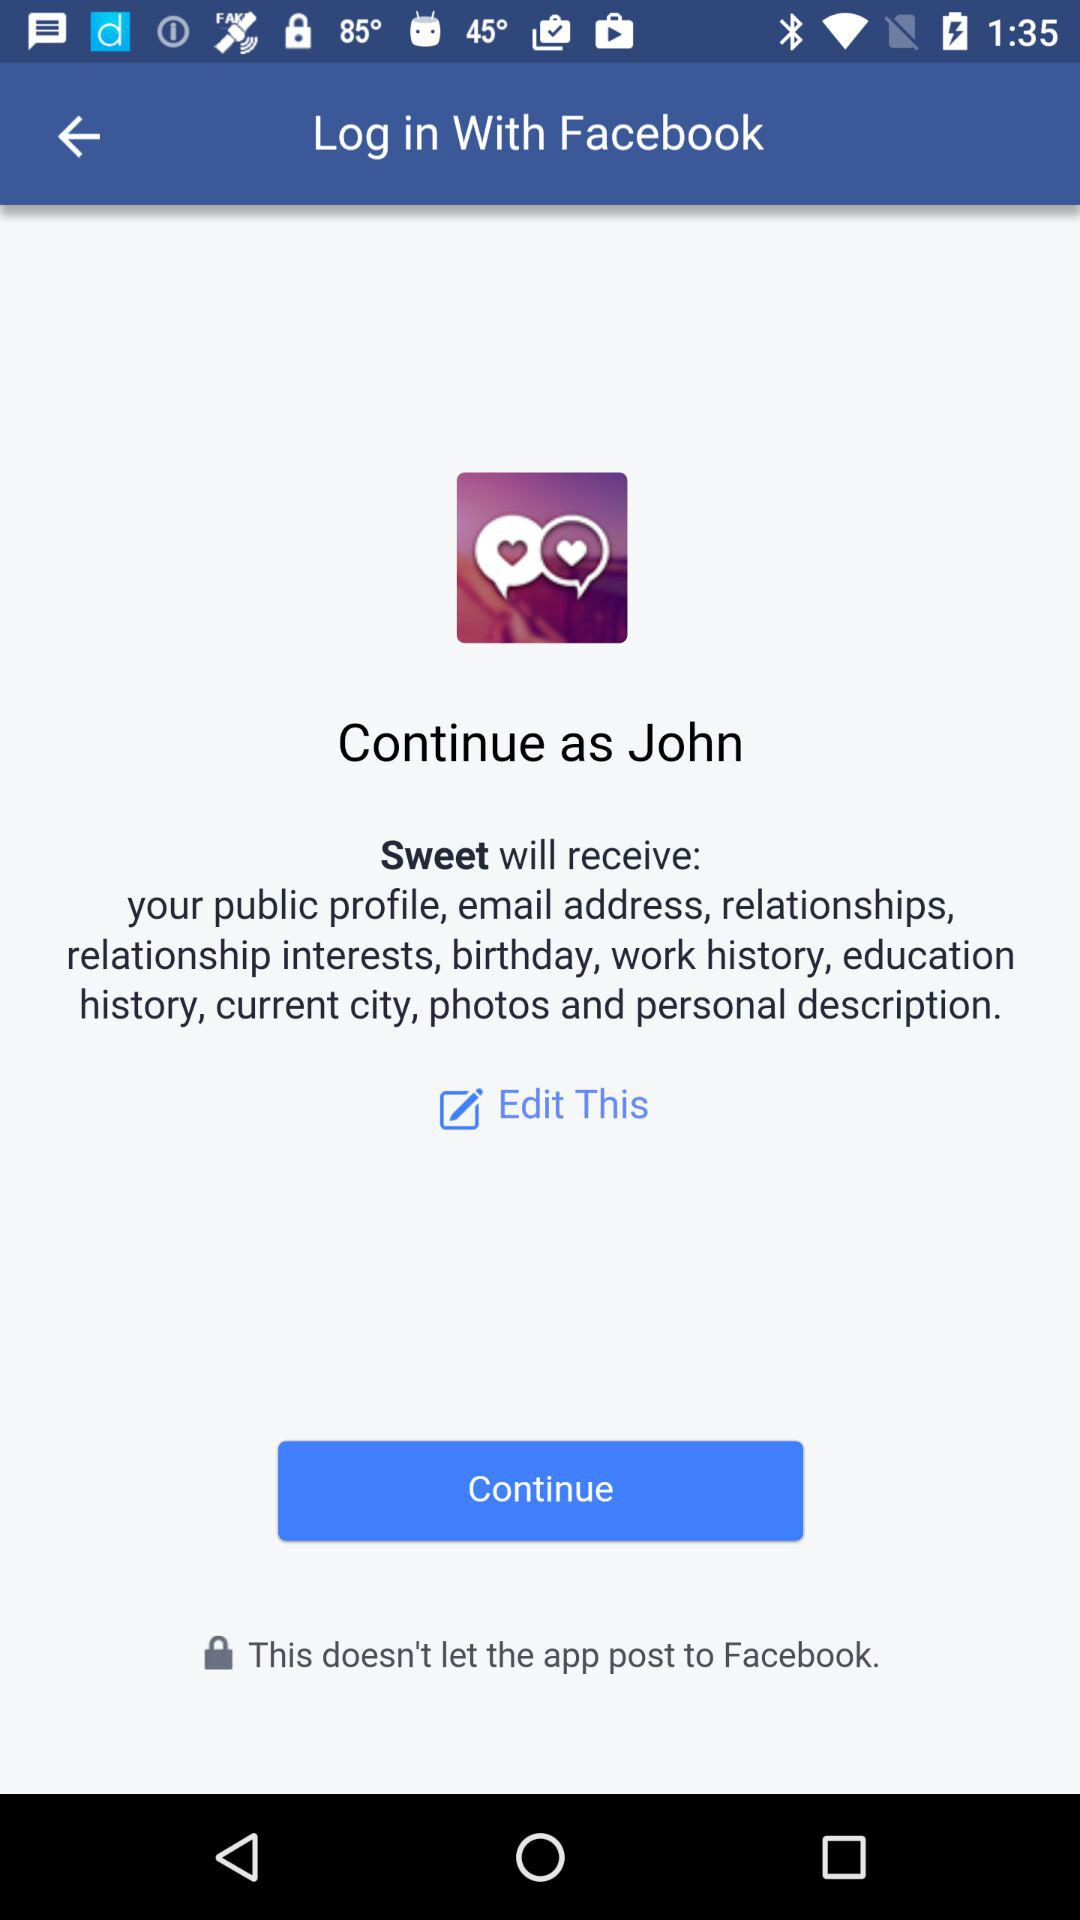What's the application name which will receive public profile and email address? The application name which will receive public profile and email address is "Sweet". 